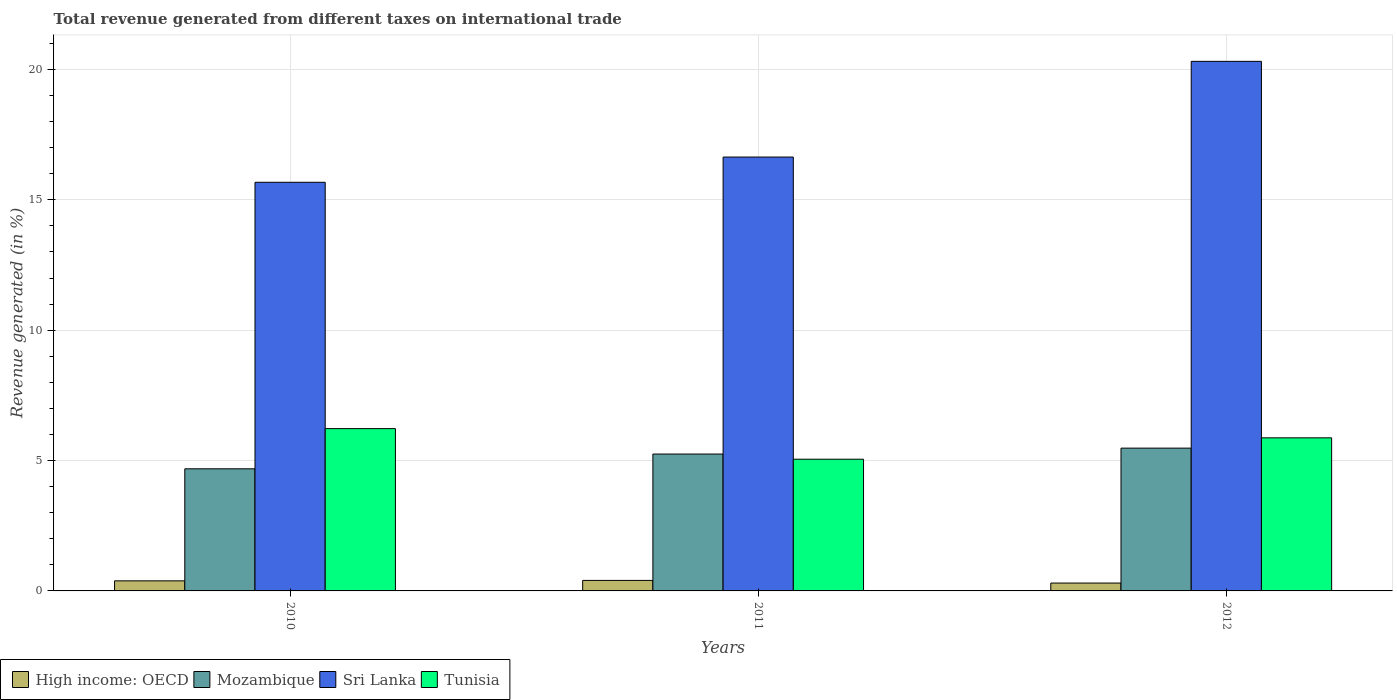How many different coloured bars are there?
Ensure brevity in your answer.  4. Are the number of bars per tick equal to the number of legend labels?
Keep it short and to the point. Yes. Are the number of bars on each tick of the X-axis equal?
Make the answer very short. Yes. What is the label of the 3rd group of bars from the left?
Your answer should be very brief. 2012. What is the total revenue generated in Tunisia in 2010?
Make the answer very short. 6.23. Across all years, what is the maximum total revenue generated in Mozambique?
Your response must be concise. 5.48. Across all years, what is the minimum total revenue generated in High income: OECD?
Keep it short and to the point. 0.3. What is the total total revenue generated in High income: OECD in the graph?
Your response must be concise. 1.09. What is the difference between the total revenue generated in High income: OECD in 2011 and that in 2012?
Your answer should be very brief. 0.1. What is the difference between the total revenue generated in High income: OECD in 2011 and the total revenue generated in Tunisia in 2010?
Provide a succinct answer. -5.82. What is the average total revenue generated in Tunisia per year?
Your answer should be very brief. 5.72. In the year 2012, what is the difference between the total revenue generated in Tunisia and total revenue generated in Sri Lanka?
Offer a terse response. -14.44. In how many years, is the total revenue generated in Mozambique greater than 4 %?
Your answer should be compact. 3. What is the ratio of the total revenue generated in Tunisia in 2010 to that in 2011?
Keep it short and to the point. 1.23. Is the total revenue generated in High income: OECD in 2010 less than that in 2012?
Your answer should be very brief. No. Is the difference between the total revenue generated in Tunisia in 2010 and 2012 greater than the difference between the total revenue generated in Sri Lanka in 2010 and 2012?
Ensure brevity in your answer.  Yes. What is the difference between the highest and the second highest total revenue generated in Tunisia?
Offer a very short reply. 0.35. What is the difference between the highest and the lowest total revenue generated in High income: OECD?
Make the answer very short. 0.1. In how many years, is the total revenue generated in High income: OECD greater than the average total revenue generated in High income: OECD taken over all years?
Ensure brevity in your answer.  2. Is it the case that in every year, the sum of the total revenue generated in High income: OECD and total revenue generated in Sri Lanka is greater than the sum of total revenue generated in Mozambique and total revenue generated in Tunisia?
Give a very brief answer. No. What does the 1st bar from the left in 2010 represents?
Offer a terse response. High income: OECD. What does the 1st bar from the right in 2012 represents?
Your answer should be compact. Tunisia. Is it the case that in every year, the sum of the total revenue generated in Mozambique and total revenue generated in Sri Lanka is greater than the total revenue generated in Tunisia?
Your answer should be compact. Yes. Does the graph contain any zero values?
Give a very brief answer. No. Where does the legend appear in the graph?
Offer a very short reply. Bottom left. How many legend labels are there?
Your answer should be compact. 4. What is the title of the graph?
Provide a short and direct response. Total revenue generated from different taxes on international trade. Does "St. Lucia" appear as one of the legend labels in the graph?
Make the answer very short. No. What is the label or title of the Y-axis?
Offer a very short reply. Revenue generated (in %). What is the Revenue generated (in %) of High income: OECD in 2010?
Your answer should be compact. 0.39. What is the Revenue generated (in %) in Mozambique in 2010?
Your response must be concise. 4.68. What is the Revenue generated (in %) in Sri Lanka in 2010?
Your response must be concise. 15.67. What is the Revenue generated (in %) of Tunisia in 2010?
Make the answer very short. 6.23. What is the Revenue generated (in %) of High income: OECD in 2011?
Make the answer very short. 0.4. What is the Revenue generated (in %) of Mozambique in 2011?
Your answer should be very brief. 5.25. What is the Revenue generated (in %) in Sri Lanka in 2011?
Your response must be concise. 16.64. What is the Revenue generated (in %) in Tunisia in 2011?
Keep it short and to the point. 5.05. What is the Revenue generated (in %) of High income: OECD in 2012?
Ensure brevity in your answer.  0.3. What is the Revenue generated (in %) of Mozambique in 2012?
Offer a very short reply. 5.48. What is the Revenue generated (in %) of Sri Lanka in 2012?
Keep it short and to the point. 20.31. What is the Revenue generated (in %) of Tunisia in 2012?
Your response must be concise. 5.87. Across all years, what is the maximum Revenue generated (in %) of High income: OECD?
Keep it short and to the point. 0.4. Across all years, what is the maximum Revenue generated (in %) in Mozambique?
Provide a succinct answer. 5.48. Across all years, what is the maximum Revenue generated (in %) in Sri Lanka?
Your response must be concise. 20.31. Across all years, what is the maximum Revenue generated (in %) of Tunisia?
Provide a succinct answer. 6.23. Across all years, what is the minimum Revenue generated (in %) of High income: OECD?
Provide a succinct answer. 0.3. Across all years, what is the minimum Revenue generated (in %) in Mozambique?
Provide a short and direct response. 4.68. Across all years, what is the minimum Revenue generated (in %) in Sri Lanka?
Offer a terse response. 15.67. Across all years, what is the minimum Revenue generated (in %) in Tunisia?
Make the answer very short. 5.05. What is the total Revenue generated (in %) of High income: OECD in the graph?
Give a very brief answer. 1.09. What is the total Revenue generated (in %) of Mozambique in the graph?
Keep it short and to the point. 15.41. What is the total Revenue generated (in %) of Sri Lanka in the graph?
Offer a terse response. 52.63. What is the total Revenue generated (in %) of Tunisia in the graph?
Make the answer very short. 17.15. What is the difference between the Revenue generated (in %) in High income: OECD in 2010 and that in 2011?
Provide a succinct answer. -0.02. What is the difference between the Revenue generated (in %) of Mozambique in 2010 and that in 2011?
Your answer should be compact. -0.57. What is the difference between the Revenue generated (in %) in Sri Lanka in 2010 and that in 2011?
Make the answer very short. -0.97. What is the difference between the Revenue generated (in %) in Tunisia in 2010 and that in 2011?
Your response must be concise. 1.17. What is the difference between the Revenue generated (in %) of High income: OECD in 2010 and that in 2012?
Provide a succinct answer. 0.08. What is the difference between the Revenue generated (in %) of Mozambique in 2010 and that in 2012?
Give a very brief answer. -0.79. What is the difference between the Revenue generated (in %) in Sri Lanka in 2010 and that in 2012?
Offer a terse response. -4.64. What is the difference between the Revenue generated (in %) of Tunisia in 2010 and that in 2012?
Your answer should be compact. 0.35. What is the difference between the Revenue generated (in %) of High income: OECD in 2011 and that in 2012?
Keep it short and to the point. 0.1. What is the difference between the Revenue generated (in %) in Mozambique in 2011 and that in 2012?
Your answer should be compact. -0.23. What is the difference between the Revenue generated (in %) of Sri Lanka in 2011 and that in 2012?
Ensure brevity in your answer.  -3.67. What is the difference between the Revenue generated (in %) of Tunisia in 2011 and that in 2012?
Offer a very short reply. -0.82. What is the difference between the Revenue generated (in %) of High income: OECD in 2010 and the Revenue generated (in %) of Mozambique in 2011?
Your answer should be very brief. -4.86. What is the difference between the Revenue generated (in %) in High income: OECD in 2010 and the Revenue generated (in %) in Sri Lanka in 2011?
Offer a terse response. -16.26. What is the difference between the Revenue generated (in %) of High income: OECD in 2010 and the Revenue generated (in %) of Tunisia in 2011?
Make the answer very short. -4.67. What is the difference between the Revenue generated (in %) of Mozambique in 2010 and the Revenue generated (in %) of Sri Lanka in 2011?
Keep it short and to the point. -11.96. What is the difference between the Revenue generated (in %) in Mozambique in 2010 and the Revenue generated (in %) in Tunisia in 2011?
Ensure brevity in your answer.  -0.37. What is the difference between the Revenue generated (in %) of Sri Lanka in 2010 and the Revenue generated (in %) of Tunisia in 2011?
Your answer should be very brief. 10.62. What is the difference between the Revenue generated (in %) of High income: OECD in 2010 and the Revenue generated (in %) of Mozambique in 2012?
Your answer should be very brief. -5.09. What is the difference between the Revenue generated (in %) of High income: OECD in 2010 and the Revenue generated (in %) of Sri Lanka in 2012?
Give a very brief answer. -19.93. What is the difference between the Revenue generated (in %) in High income: OECD in 2010 and the Revenue generated (in %) in Tunisia in 2012?
Give a very brief answer. -5.49. What is the difference between the Revenue generated (in %) in Mozambique in 2010 and the Revenue generated (in %) in Sri Lanka in 2012?
Offer a very short reply. -15.63. What is the difference between the Revenue generated (in %) in Mozambique in 2010 and the Revenue generated (in %) in Tunisia in 2012?
Your response must be concise. -1.19. What is the difference between the Revenue generated (in %) of Sri Lanka in 2010 and the Revenue generated (in %) of Tunisia in 2012?
Keep it short and to the point. 9.8. What is the difference between the Revenue generated (in %) in High income: OECD in 2011 and the Revenue generated (in %) in Mozambique in 2012?
Make the answer very short. -5.07. What is the difference between the Revenue generated (in %) in High income: OECD in 2011 and the Revenue generated (in %) in Sri Lanka in 2012?
Your response must be concise. -19.91. What is the difference between the Revenue generated (in %) in High income: OECD in 2011 and the Revenue generated (in %) in Tunisia in 2012?
Give a very brief answer. -5.47. What is the difference between the Revenue generated (in %) in Mozambique in 2011 and the Revenue generated (in %) in Sri Lanka in 2012?
Your answer should be very brief. -15.06. What is the difference between the Revenue generated (in %) of Mozambique in 2011 and the Revenue generated (in %) of Tunisia in 2012?
Provide a succinct answer. -0.62. What is the difference between the Revenue generated (in %) in Sri Lanka in 2011 and the Revenue generated (in %) in Tunisia in 2012?
Provide a short and direct response. 10.77. What is the average Revenue generated (in %) of High income: OECD per year?
Offer a very short reply. 0.36. What is the average Revenue generated (in %) in Mozambique per year?
Give a very brief answer. 5.14. What is the average Revenue generated (in %) in Sri Lanka per year?
Provide a short and direct response. 17.54. What is the average Revenue generated (in %) of Tunisia per year?
Keep it short and to the point. 5.72. In the year 2010, what is the difference between the Revenue generated (in %) of High income: OECD and Revenue generated (in %) of Mozambique?
Offer a terse response. -4.3. In the year 2010, what is the difference between the Revenue generated (in %) of High income: OECD and Revenue generated (in %) of Sri Lanka?
Your response must be concise. -15.29. In the year 2010, what is the difference between the Revenue generated (in %) of High income: OECD and Revenue generated (in %) of Tunisia?
Make the answer very short. -5.84. In the year 2010, what is the difference between the Revenue generated (in %) of Mozambique and Revenue generated (in %) of Sri Lanka?
Provide a short and direct response. -10.99. In the year 2010, what is the difference between the Revenue generated (in %) in Mozambique and Revenue generated (in %) in Tunisia?
Give a very brief answer. -1.54. In the year 2010, what is the difference between the Revenue generated (in %) of Sri Lanka and Revenue generated (in %) of Tunisia?
Your answer should be compact. 9.45. In the year 2011, what is the difference between the Revenue generated (in %) of High income: OECD and Revenue generated (in %) of Mozambique?
Provide a short and direct response. -4.85. In the year 2011, what is the difference between the Revenue generated (in %) in High income: OECD and Revenue generated (in %) in Sri Lanka?
Your response must be concise. -16.24. In the year 2011, what is the difference between the Revenue generated (in %) in High income: OECD and Revenue generated (in %) in Tunisia?
Make the answer very short. -4.65. In the year 2011, what is the difference between the Revenue generated (in %) of Mozambique and Revenue generated (in %) of Sri Lanka?
Offer a terse response. -11.39. In the year 2011, what is the difference between the Revenue generated (in %) in Mozambique and Revenue generated (in %) in Tunisia?
Make the answer very short. 0.2. In the year 2011, what is the difference between the Revenue generated (in %) in Sri Lanka and Revenue generated (in %) in Tunisia?
Keep it short and to the point. 11.59. In the year 2012, what is the difference between the Revenue generated (in %) of High income: OECD and Revenue generated (in %) of Mozambique?
Ensure brevity in your answer.  -5.17. In the year 2012, what is the difference between the Revenue generated (in %) in High income: OECD and Revenue generated (in %) in Sri Lanka?
Your answer should be very brief. -20.01. In the year 2012, what is the difference between the Revenue generated (in %) of High income: OECD and Revenue generated (in %) of Tunisia?
Keep it short and to the point. -5.57. In the year 2012, what is the difference between the Revenue generated (in %) of Mozambique and Revenue generated (in %) of Sri Lanka?
Make the answer very short. -14.84. In the year 2012, what is the difference between the Revenue generated (in %) of Mozambique and Revenue generated (in %) of Tunisia?
Offer a terse response. -0.4. In the year 2012, what is the difference between the Revenue generated (in %) of Sri Lanka and Revenue generated (in %) of Tunisia?
Make the answer very short. 14.44. What is the ratio of the Revenue generated (in %) of High income: OECD in 2010 to that in 2011?
Your answer should be very brief. 0.96. What is the ratio of the Revenue generated (in %) of Mozambique in 2010 to that in 2011?
Ensure brevity in your answer.  0.89. What is the ratio of the Revenue generated (in %) of Sri Lanka in 2010 to that in 2011?
Your answer should be very brief. 0.94. What is the ratio of the Revenue generated (in %) of Tunisia in 2010 to that in 2011?
Your answer should be very brief. 1.23. What is the ratio of the Revenue generated (in %) of High income: OECD in 2010 to that in 2012?
Offer a terse response. 1.28. What is the ratio of the Revenue generated (in %) in Mozambique in 2010 to that in 2012?
Ensure brevity in your answer.  0.86. What is the ratio of the Revenue generated (in %) in Sri Lanka in 2010 to that in 2012?
Provide a succinct answer. 0.77. What is the ratio of the Revenue generated (in %) of Tunisia in 2010 to that in 2012?
Offer a terse response. 1.06. What is the ratio of the Revenue generated (in %) in High income: OECD in 2011 to that in 2012?
Provide a succinct answer. 1.33. What is the ratio of the Revenue generated (in %) of Mozambique in 2011 to that in 2012?
Your answer should be very brief. 0.96. What is the ratio of the Revenue generated (in %) of Sri Lanka in 2011 to that in 2012?
Give a very brief answer. 0.82. What is the ratio of the Revenue generated (in %) in Tunisia in 2011 to that in 2012?
Provide a succinct answer. 0.86. What is the difference between the highest and the second highest Revenue generated (in %) in High income: OECD?
Make the answer very short. 0.02. What is the difference between the highest and the second highest Revenue generated (in %) of Mozambique?
Keep it short and to the point. 0.23. What is the difference between the highest and the second highest Revenue generated (in %) of Sri Lanka?
Keep it short and to the point. 3.67. What is the difference between the highest and the second highest Revenue generated (in %) of Tunisia?
Keep it short and to the point. 0.35. What is the difference between the highest and the lowest Revenue generated (in %) in High income: OECD?
Your response must be concise. 0.1. What is the difference between the highest and the lowest Revenue generated (in %) of Mozambique?
Offer a terse response. 0.79. What is the difference between the highest and the lowest Revenue generated (in %) in Sri Lanka?
Your answer should be compact. 4.64. What is the difference between the highest and the lowest Revenue generated (in %) of Tunisia?
Offer a very short reply. 1.17. 